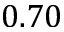Convert formula to latex. <formula><loc_0><loc_0><loc_500><loc_500>0 . 7 0</formula> 